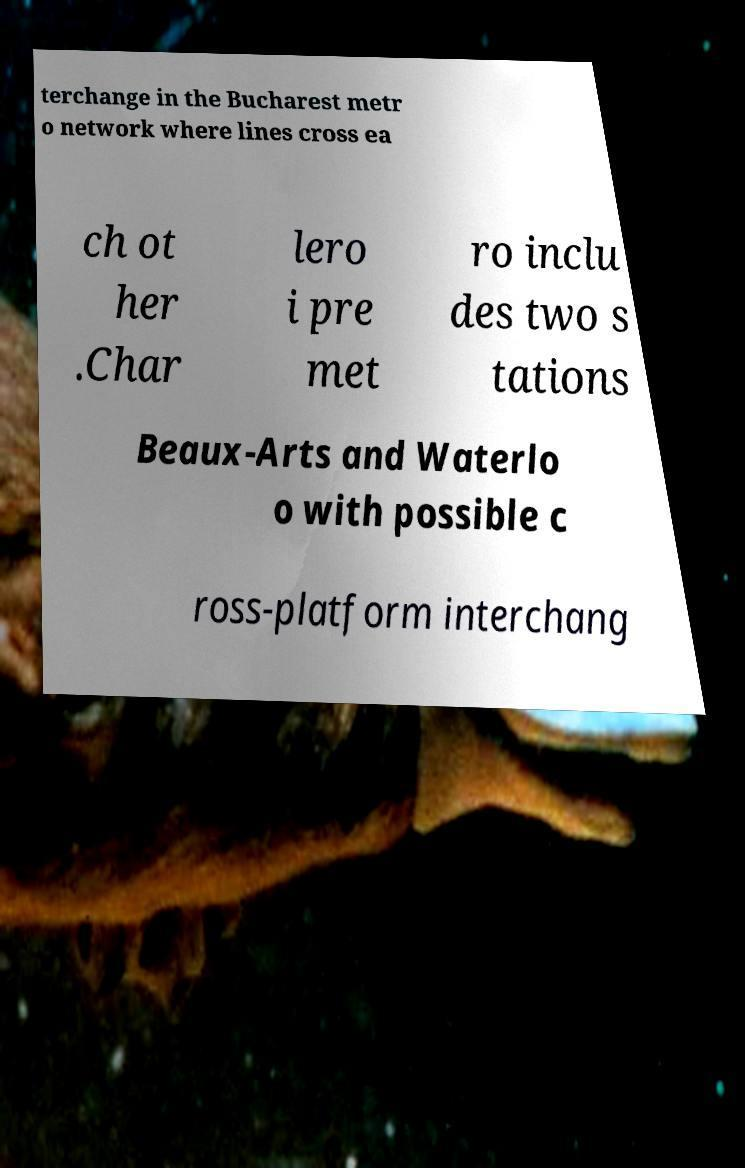There's text embedded in this image that I need extracted. Can you transcribe it verbatim? terchange in the Bucharest metr o network where lines cross ea ch ot her .Char lero i pre met ro inclu des two s tations Beaux-Arts and Waterlo o with possible c ross-platform interchang 